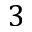Convert formula to latex. <formula><loc_0><loc_0><loc_500><loc_500>3</formula> 